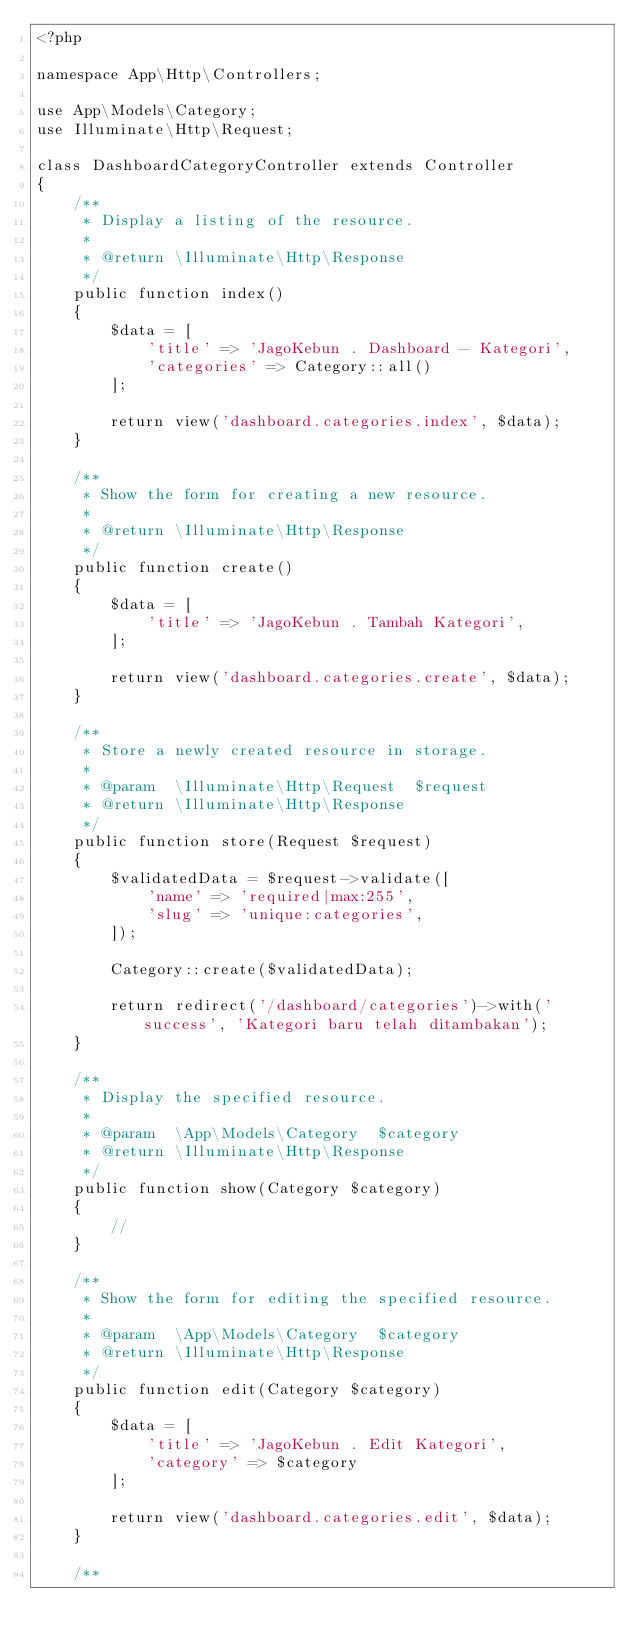<code> <loc_0><loc_0><loc_500><loc_500><_PHP_><?php

namespace App\Http\Controllers;

use App\Models\Category;
use Illuminate\Http\Request;

class DashboardCategoryController extends Controller
{
    /**
     * Display a listing of the resource.
     *
     * @return \Illuminate\Http\Response
     */
    public function index()
    {
        $data = [
            'title' => 'JagoKebun . Dashboard - Kategori',
            'categories' => Category::all()
        ];

        return view('dashboard.categories.index', $data);
    }

    /**
     * Show the form for creating a new resource.
     *
     * @return \Illuminate\Http\Response
     */
    public function create()
    {
        $data = [
            'title' => 'JagoKebun . Tambah Kategori',
        ];

        return view('dashboard.categories.create', $data);
    }

    /**
     * Store a newly created resource in storage.
     *
     * @param  \Illuminate\Http\Request  $request
     * @return \Illuminate\Http\Response
     */
    public function store(Request $request)
    {
        $validatedData = $request->validate([
            'name' => 'required|max:255',
            'slug' => 'unique:categories',
        ]);

        Category::create($validatedData);

        return redirect('/dashboard/categories')->with('success', 'Kategori baru telah ditambakan');
    }

    /**
     * Display the specified resource.
     *
     * @param  \App\Models\Category  $category
     * @return \Illuminate\Http\Response
     */
    public function show(Category $category)
    {
        //
    }

    /**
     * Show the form for editing the specified resource.
     *
     * @param  \App\Models\Category  $category
     * @return \Illuminate\Http\Response
     */
    public function edit(Category $category)
    {
        $data = [
            'title' => 'JagoKebun . Edit Kategori',
            'category' => $category
        ];

        return view('dashboard.categories.edit', $data);
    }

    /**</code> 